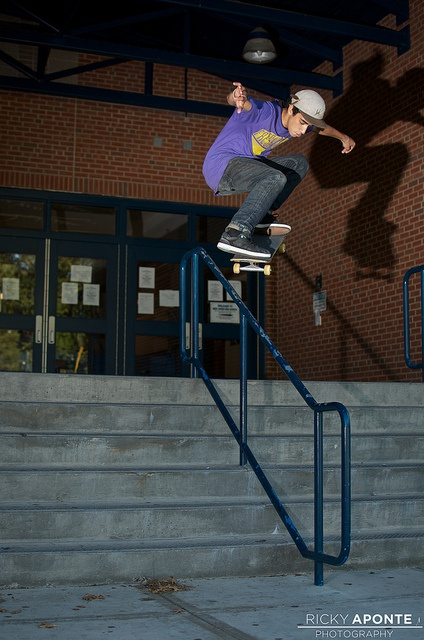Describe the objects in this image and their specific colors. I can see people in black, gray, and blue tones and skateboard in black, gray, khaki, and darkgray tones in this image. 